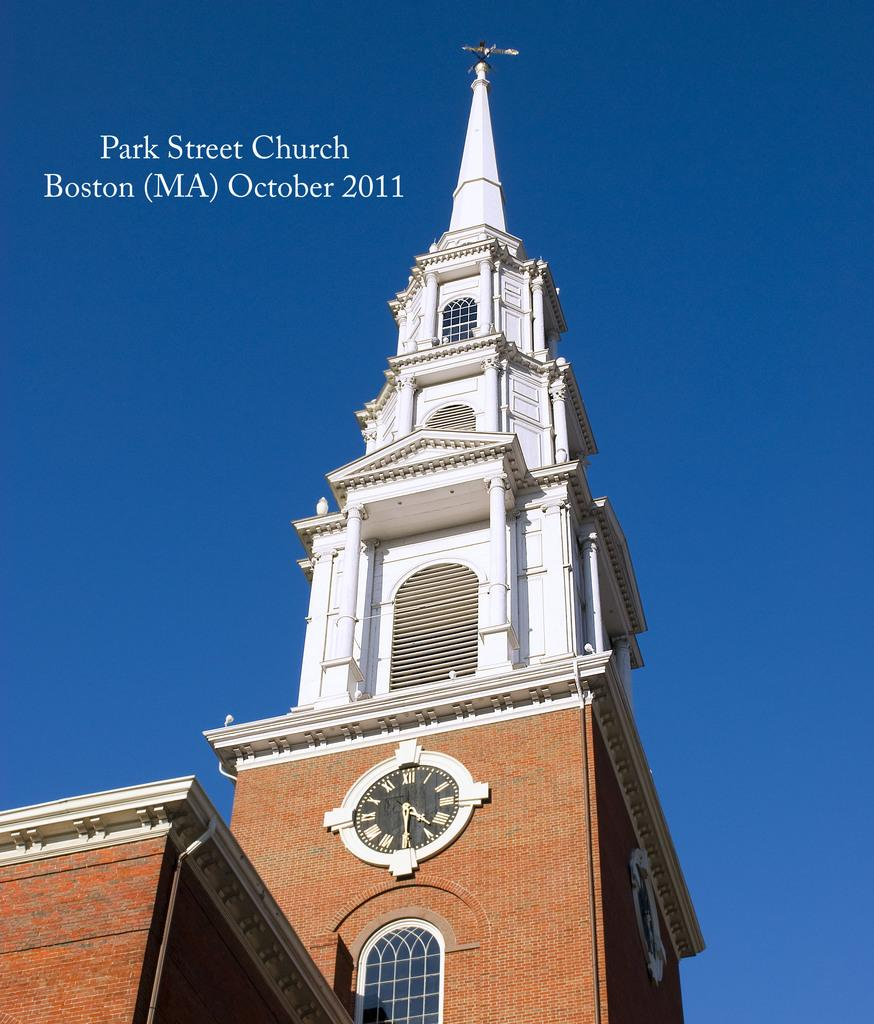<image>
Relay a brief, clear account of the picture shown. The Park Street Church is shown in October 2011. 